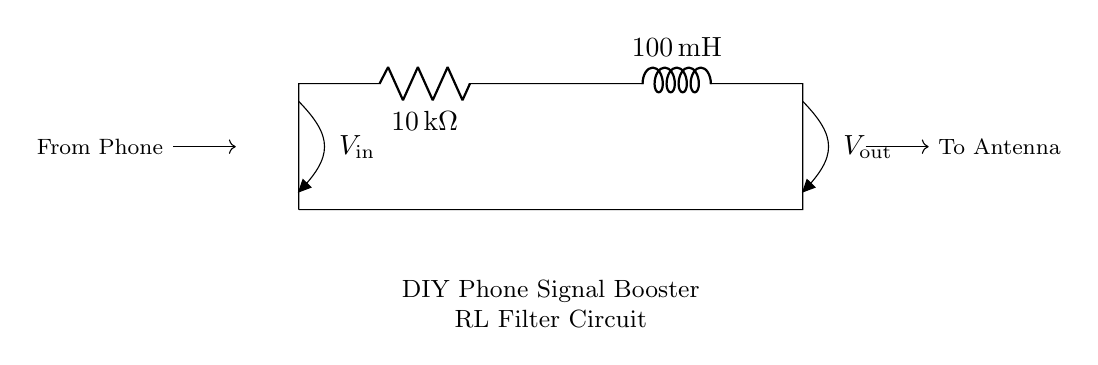What are the values of the resistor and inductor? The resistor value is 10 kilohms and the inductor value is 100 millihenrys. These values are indicated on the components in the circuit schematic.
Answer: 10 kilohms, 100 millihenrys What type of filter is this circuit designed to be? This circuit is a low-pass filter, which allows low-frequency signals to pass while attenuating high-frequency signals, as indicated by the configuration of the resistor and inductor.
Answer: Low-pass filter What does V_in refer to in this circuit? V_in refers to the input voltage from the phone, which is the signal coming into the circuit from the left side where it is connected.
Answer: Input voltage from phone What is the significance of L in the circuit? L represents the inductor, which stores energy in a magnetic field when electrical current flows through it, affecting the circuit's response to changes in current over time.
Answer: Inductor How does the resistor influence the cutoff frequency? The resistor, in conjunction with the inductor, determines the cutoff frequency of the filter. The cutoff frequency can be calculated using the formula f_c = 1/(2π√(LC)), where L is the inductor and C is the capacitance if present, which impacts how quickly the circuit responds to changes.
Answer: Determines cutoff frequency What does V_out represent in this circuit? V_out is the output voltage across the inductor, which corresponds to the signal that is being sent to the antenna after filtering.
Answer: Output voltage to antenna How does the RL circuit affect high-frequency signals? The RL circuit attenuates high-frequency signals because as frequency increases, the inductive reactance rises, reducing the amplitude of the output voltage as seen at V_out, resulting in less high-frequency noise.
Answer: Attenuates high-frequency signals 